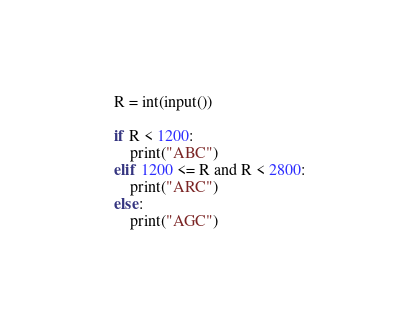Convert code to text. <code><loc_0><loc_0><loc_500><loc_500><_Python_>R = int(input())

if R < 1200:
    print("ABC")
elif 1200 <= R and R < 2800:
    print("ARC")
else:
    print("AGC")</code> 